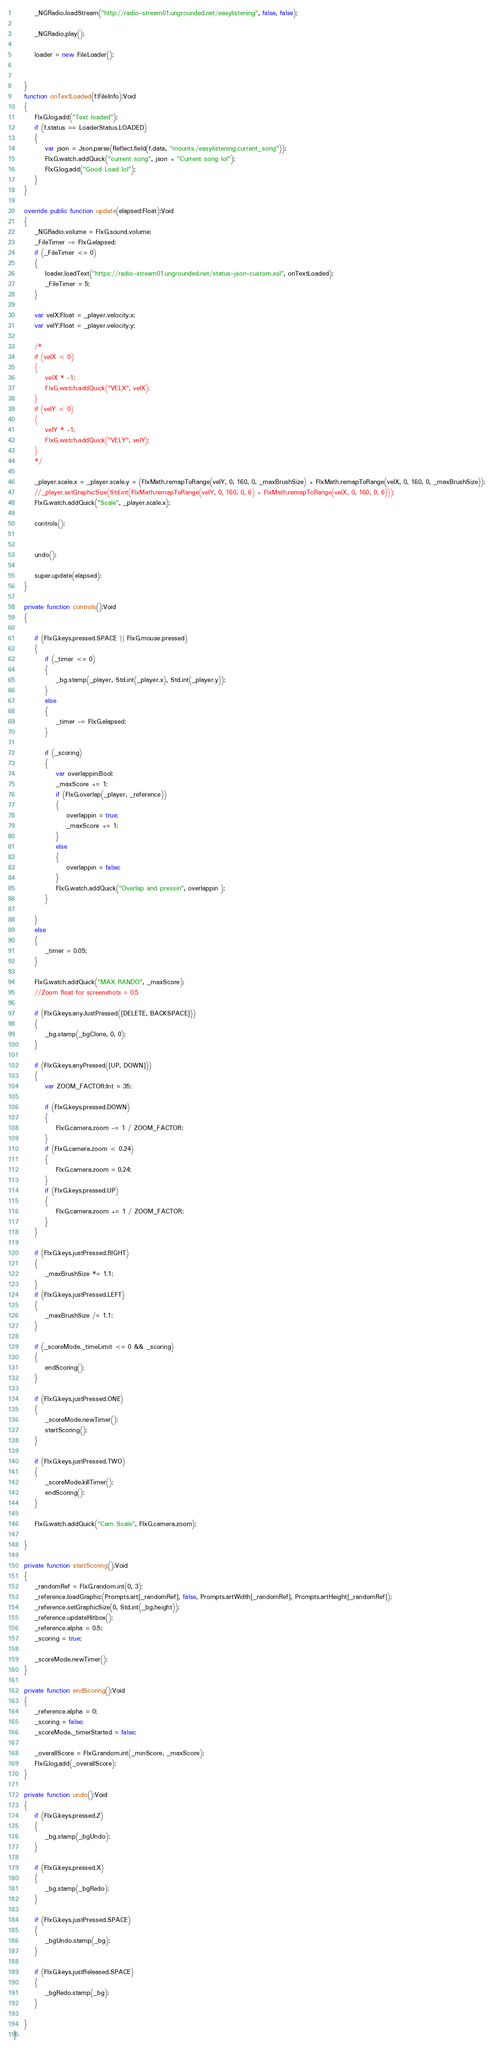Convert code to text. <code><loc_0><loc_0><loc_500><loc_500><_Haxe_>		_NGRadio.loadStream("http://radio-stream01.ungrounded.net/easylistening", false, false);
		
		_NGRadio.play();
		
		loader = new FileLoader();
		
		
	}
	function onTextLoaded(f:FileInfo):Void
	{
		FlxG.log.add("Text loaded");
		if (f.status == LoaderStatus.LOADED)
		{
			var json = Json.parse(Reflect.field(f.data, "mounts./easylistening.current_song"));
			FlxG.watch.addQuick("current song", json + "Current song lol");
			FlxG.log.add("Good Load lol");
		}
	}

	override public function update(elapsed:Float):Void
	{
		_NGRadio.volume = FlxG.sound.volume;
		_FileTimer -= FlxG.elapsed;
		if (_FileTimer <= 0)
		{
			loader.loadText("https://radio-stream01.ungrounded.net/status-json-custom.xsl", onTextLoaded);
			_FileTimer = 5;
		}
		
		var velX:Float = _player.velocity.x;
		var velY:Float = _player.velocity.y;
		
		/*
		if (velX < 0)
		{
			velX * -1;
			FlxG.watch.addQuick("VELX", velX);
		}
		if (velY < 0)
		{
			velY * -1;
			FlxG.watch.addQuick("VELY", velY);
		}
		*/
		
		_player.scale.x = _player.scale.y = (FlxMath.remapToRange(velY, 0, 160, 0, _maxBrushSize) + FlxMath.remapToRange(velX, 0, 160, 0, _maxBrushSize));
		//_player.setGraphicSize(Std.int(FlxMath.remapToRange(velY, 0, 160, 0, 6) + FlxMath.remapToRange(velX, 0, 160, 0, 6)));
		FlxG.watch.addQuick("Scale", _player.scale.x);
		
		controls();
		
		
		undo();
		
		super.update(elapsed);
	}
	
	private function controls():Void
	{
		
		if (FlxG.keys.pressed.SPACE || FlxG.mouse.pressed)
		{
			if (_timer <= 0)
			{
				_bg.stamp(_player, Std.int(_player.x), Std.int(_player.y));
			}
			else
			{
				_timer -= FlxG.elapsed;
			}
			
			if (_scoring)
			{
				var overlappin:Bool;
				_maxScore += 1;
				if (FlxG.overlap(_player, _reference))
				{
					overlappin = true;
					_maxScore += 1;
				}
				else
				{
					overlappin = false;
				}
				FlxG.watch.addQuick("Overlap and pressin", overlappin );
			}
			
		}
		else
		{
			_timer = 0.05;
		}
		
		FlxG.watch.addQuick("MAX RANDO", _maxScore);
		//Zoom float for screenshots = 0.5
		
		if (FlxG.keys.anyJustPressed([DELETE, BACKSPACE]))
		{
			_bg.stamp(_bgClone, 0, 0);
		}
		
		if (FlxG.keys.anyPressed([UP, DOWN]))
		{
			var ZOOM_FACTOR:Int = 35;
			
			if (FlxG.keys.pressed.DOWN)
			{
				FlxG.camera.zoom -= 1 / ZOOM_FACTOR;
			}
			if (FlxG.camera.zoom < 0.24)
			{
				FlxG.camera.zoom = 0.24;
			}
			if (FlxG.keys.pressed.UP)
			{
				FlxG.camera.zoom += 1 / ZOOM_FACTOR;
			}
		}
		
		if (FlxG.keys.justPressed.RIGHT)
		{
			_maxBrushSize *= 1.1;
		}
		if (FlxG.keys.justPressed.LEFT)
		{
			_maxBrushSize /= 1.1;
		}
		
		if (_scoreMode._timeLimit <= 0 && _scoring)
		{
			endScoring();
		}
		
		if (FlxG.keys.justPressed.ONE)
		{
			_scoreMode.newTimer();
			startScoring();
		}
		
		if (FlxG.keys.justPressed.TWO)
		{
			_scoreMode.killTimer();
			endScoring();
		}
		
		FlxG.watch.addQuick("Cam Scale", FlxG.camera.zoom);
		
	}
	
	private function startScoring():Void
	{
		_randomRef = FlxG.random.int(0, 3);
		_reference.loadGraphic(Prompts.art[_randomRef], false, Prompts.artWidth[_randomRef], Prompts.artHeight[_randomRef]);
		_reference.setGraphicSize(0, Std.int(_bg.height));
		_reference.updateHitbox();
		_reference.alpha = 0.5;
		_scoring = true;
		
		_scoreMode.newTimer();
	}
	
	private function endScoring():Void
	{
		_reference.alpha = 0;
		_scoring = false;
		_scoreMode._timerStarted = false;
		
		_overallScore = FlxG.random.int(_minScore, _maxScore);
		FlxG.log.add(_overallScore);
	}
	
	private function undo():Void
	{
		if (FlxG.keys.pressed.Z)
		{
			_bg.stamp(_bgUndo);
		}
		
		if (FlxG.keys.pressed.X)
		{
			_bg.stamp(_bgRedo);
		}
		
		if (FlxG.keys.justPressed.SPACE)
		{
			_bgUndo.stamp(_bg);
		}
		
		if (FlxG.keys.justReleased.SPACE)
		{
			_bgRedo.stamp(_bg);
		}
		
	}
}</code> 